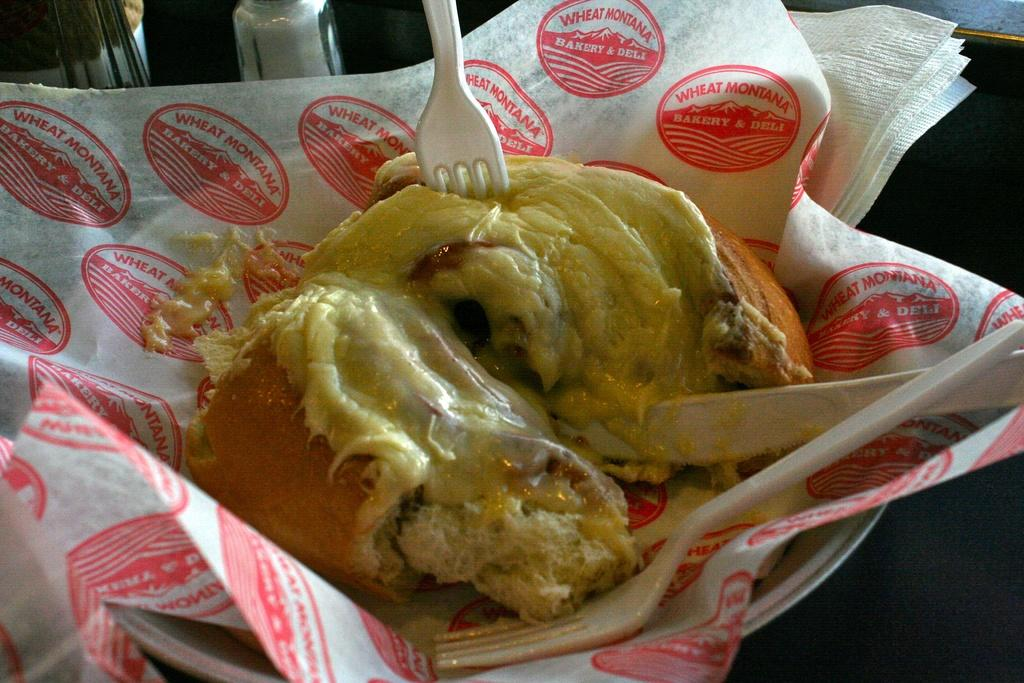What type of food is visible in the image? There is a hotdog with cheese in the image. What is the hotdog placed on? The hotdog is on a tissue. Where is the tissue with the hotdog located? The tissue with the hotdog is on a plate. What surface is the plate resting on? The plate is on a table. What utensil is used on the hotdog? There is a fork on the hotdog. What condiments are present on the table? There is a salt and pepper bottle on the table. What language is the grandmother speaking in the image? There is no grandmother present in the image, and therefore no language being spoken. 